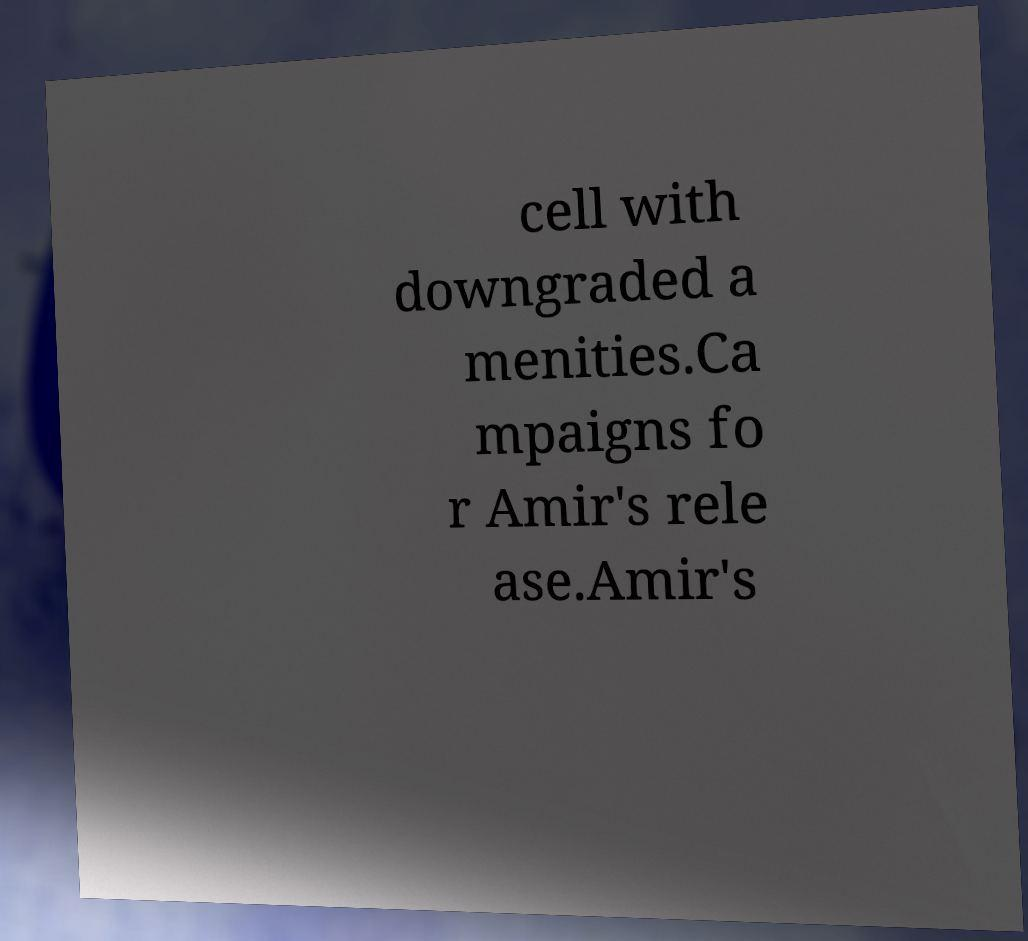Please identify and transcribe the text found in this image. cell with downgraded a menities.Ca mpaigns fo r Amir's rele ase.Amir's 